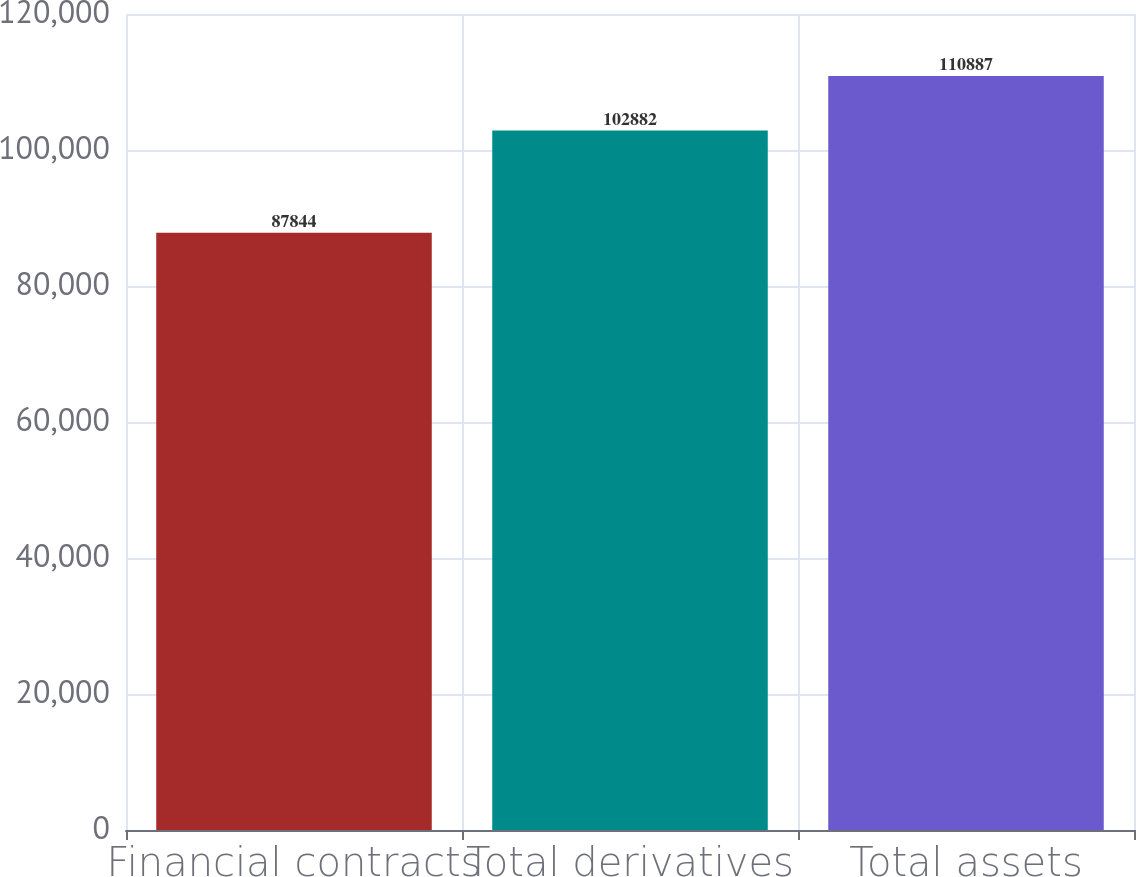<chart> <loc_0><loc_0><loc_500><loc_500><bar_chart><fcel>Financial contracts<fcel>Total derivatives<fcel>Total assets<nl><fcel>87844<fcel>102882<fcel>110887<nl></chart> 